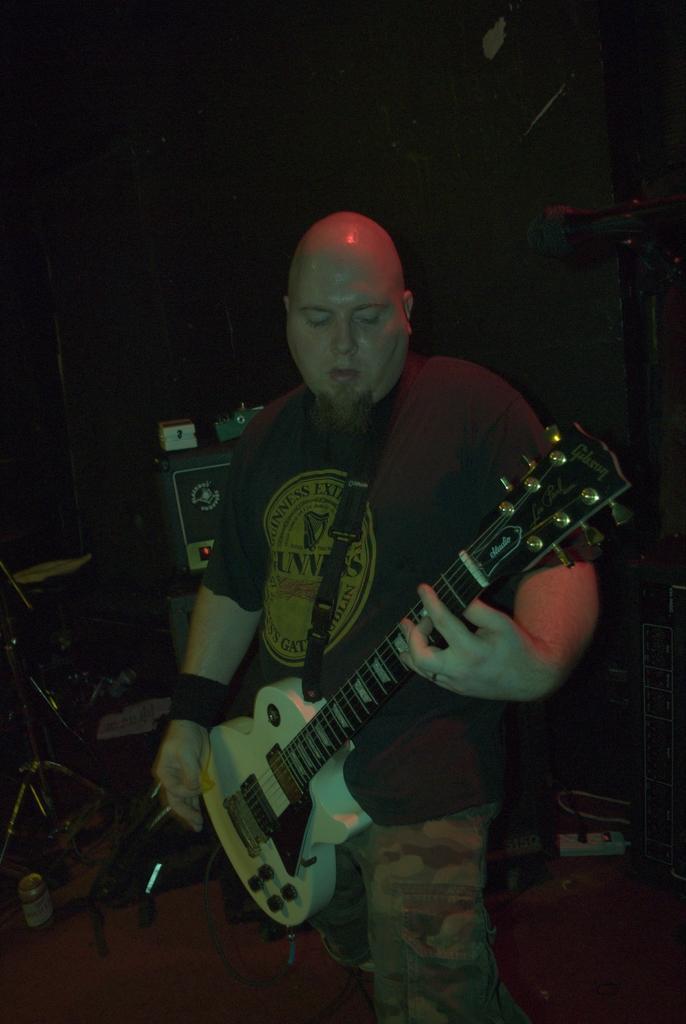Describe this image in one or two sentences. In this picture a black t shirt guy is playing a guitar , in the background we observe few musical instruments and there is a mic in the right side of the image. 